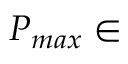<formula> <loc_0><loc_0><loc_500><loc_500>P _ { \max } \in</formula> 